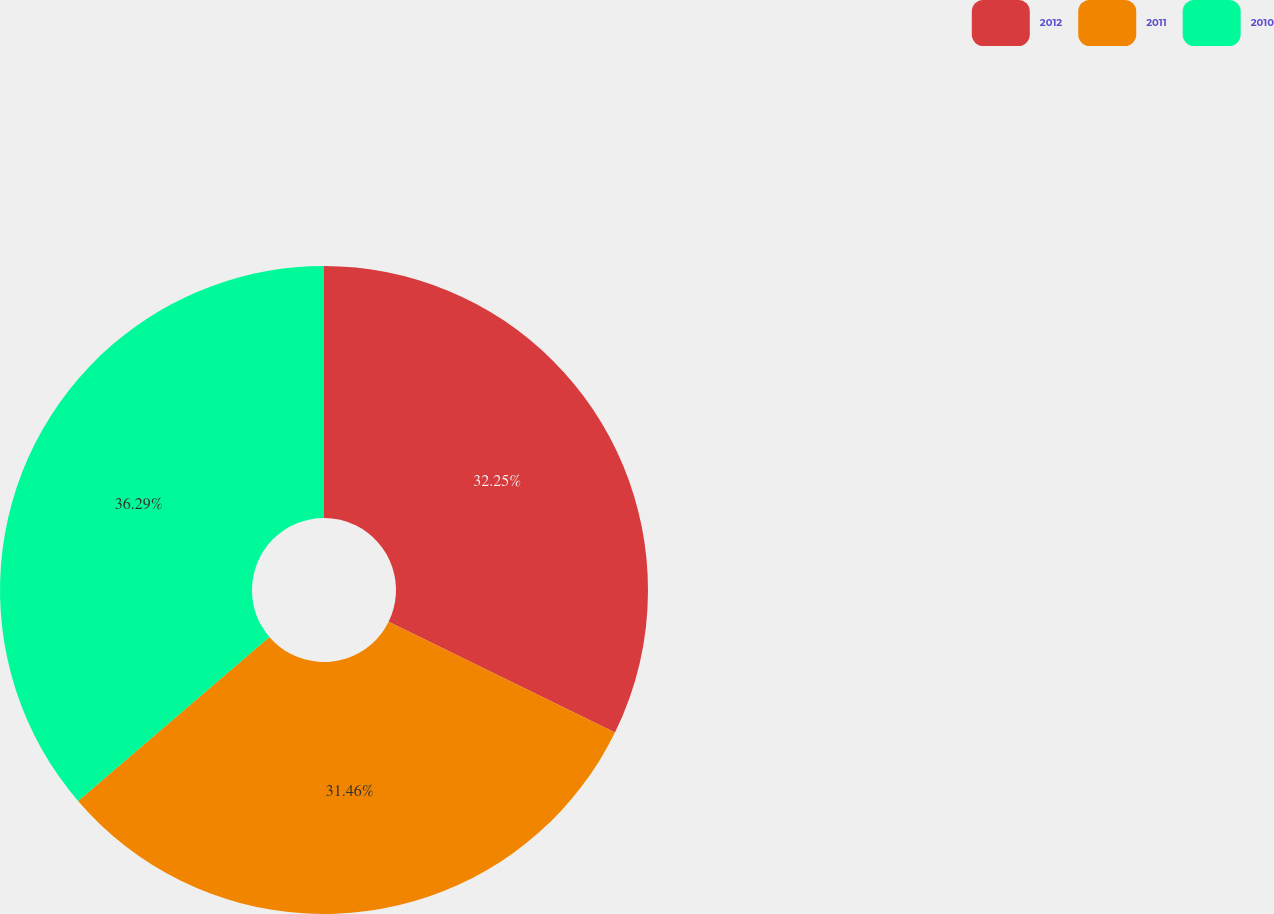Convert chart. <chart><loc_0><loc_0><loc_500><loc_500><pie_chart><fcel>2012<fcel>2011<fcel>2010<nl><fcel>32.25%<fcel>31.46%<fcel>36.28%<nl></chart> 